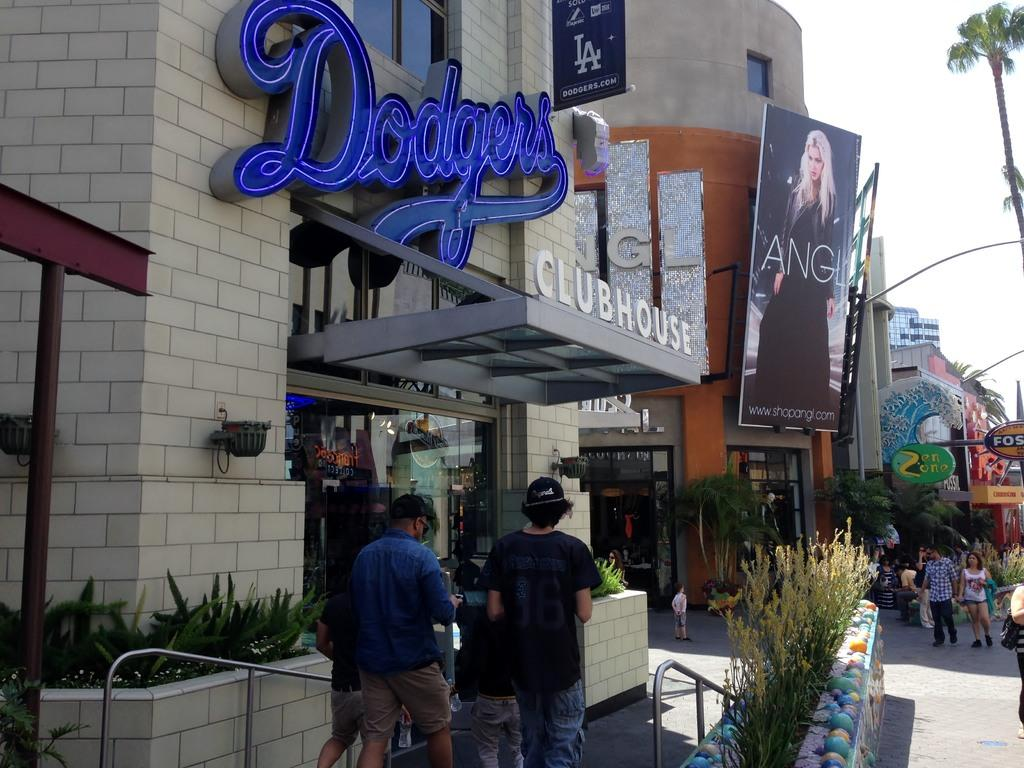Who or what can be seen in the image? There are people in the image. What structures are present in the image? There are buildings in the image. What type of vegetation is visible in the image? There are plants and trees in the image. What additional objects can be seen in the image? There are boards with text and handrails in the image. What can be seen in the sky in the image? The sky is visible in the image. What type of table is used for the discovery in the image? There is no mention of a discovery or a table in the image. What unit is being measured by the people in the image? There is no indication of any measurement or unit being used by the people in the image. 